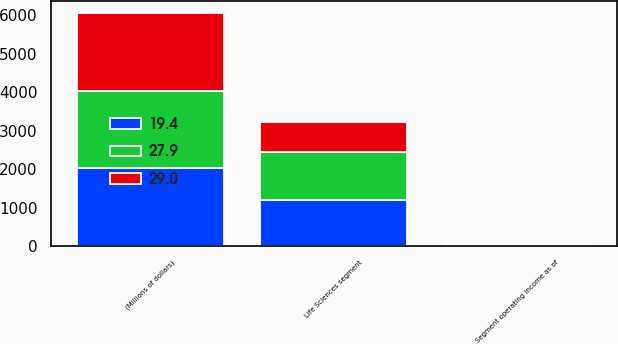Convert chart to OTSL. <chart><loc_0><loc_0><loc_500><loc_500><stacked_bar_chart><ecel><fcel>(Millions of dollars)<fcel>Life Sciences segment<fcel>Segment operating income as of<nl><fcel>27.9<fcel>2019<fcel>1248<fcel>29<nl><fcel>19.4<fcel>2018<fcel>1207<fcel>27.9<nl><fcel>29<fcel>2017<fcel>772<fcel>19.4<nl></chart> 